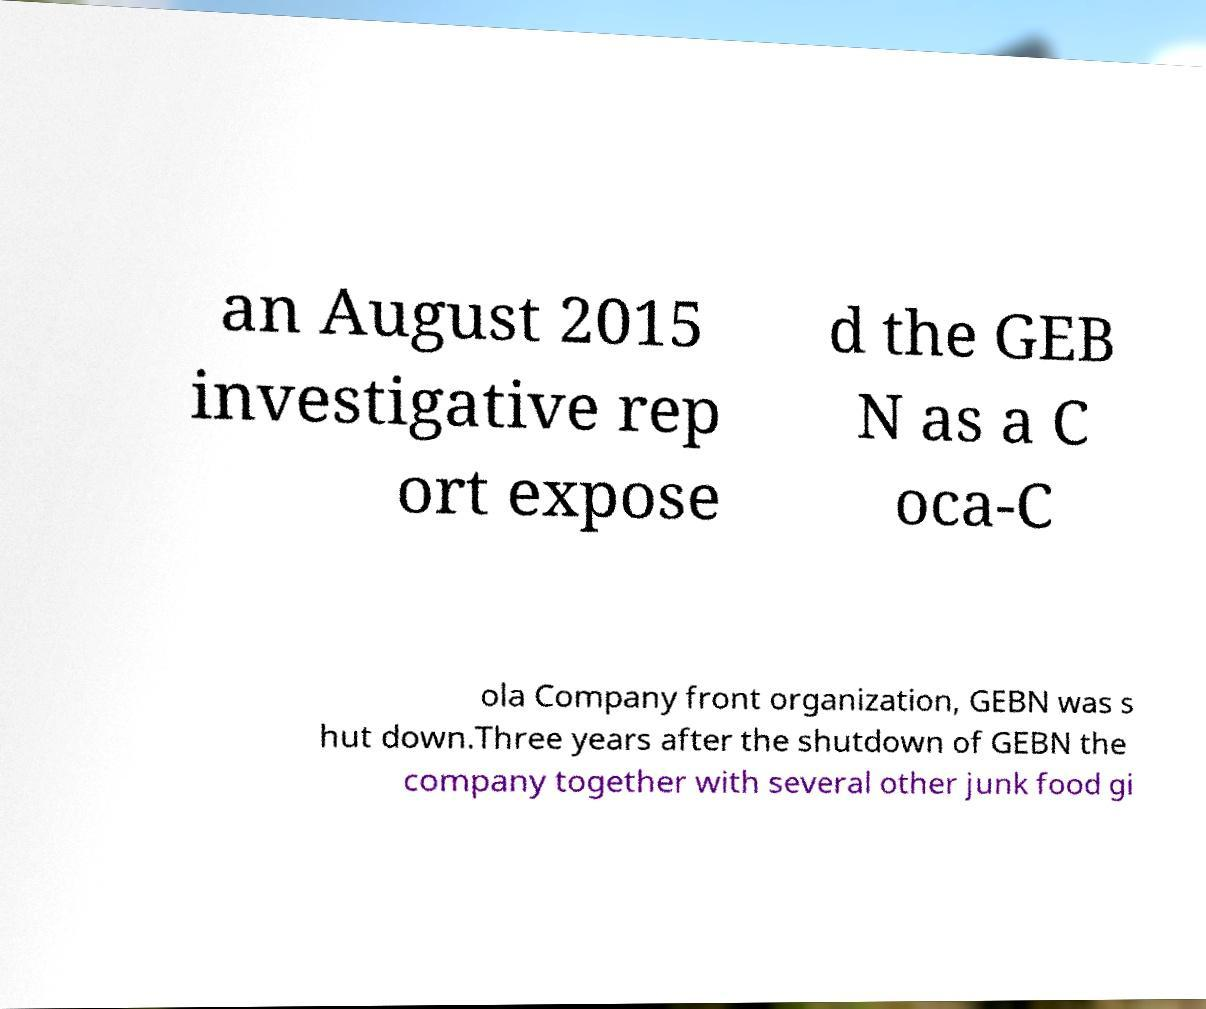For documentation purposes, I need the text within this image transcribed. Could you provide that? an August 2015 investigative rep ort expose d the GEB N as a C oca-C ola Company front organization, GEBN was s hut down.Three years after the shutdown of GEBN the company together with several other junk food gi 